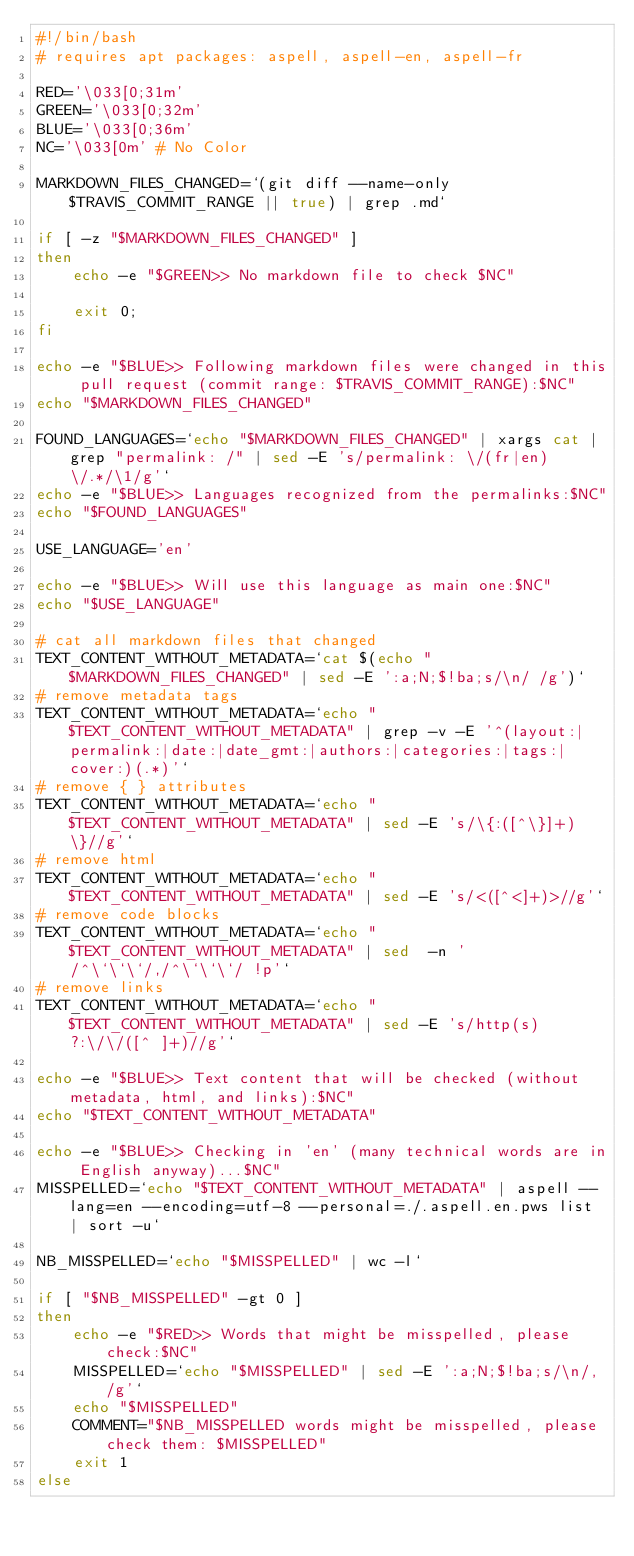<code> <loc_0><loc_0><loc_500><loc_500><_Bash_>#!/bin/bash
# requires apt packages: aspell, aspell-en, aspell-fr

RED='\033[0;31m'
GREEN='\033[0;32m'
BLUE='\033[0;36m'
NC='\033[0m' # No Color

MARKDOWN_FILES_CHANGED=`(git diff --name-only $TRAVIS_COMMIT_RANGE || true) | grep .md`

if [ -z "$MARKDOWN_FILES_CHANGED" ]
then
    echo -e "$GREEN>> No markdown file to check $NC"

    exit 0;
fi

echo -e "$BLUE>> Following markdown files were changed in this pull request (commit range: $TRAVIS_COMMIT_RANGE):$NC"
echo "$MARKDOWN_FILES_CHANGED"

FOUND_LANGUAGES=`echo "$MARKDOWN_FILES_CHANGED" | xargs cat | grep "permalink: /" | sed -E 's/permalink: \/(fr|en)\/.*/\1/g'`
echo -e "$BLUE>> Languages recognized from the permalinks:$NC"
echo "$FOUND_LANGUAGES"

USE_LANGUAGE='en'

echo -e "$BLUE>> Will use this language as main one:$NC"
echo "$USE_LANGUAGE"

# cat all markdown files that changed
TEXT_CONTENT_WITHOUT_METADATA=`cat $(echo "$MARKDOWN_FILES_CHANGED" | sed -E ':a;N;$!ba;s/\n/ /g')`
# remove metadata tags
TEXT_CONTENT_WITHOUT_METADATA=`echo "$TEXT_CONTENT_WITHOUT_METADATA" | grep -v -E '^(layout:|permalink:|date:|date_gmt:|authors:|categories:|tags:|cover:)(.*)'`
# remove { } attributes
TEXT_CONTENT_WITHOUT_METADATA=`echo "$TEXT_CONTENT_WITHOUT_METADATA" | sed -E 's/\{:([^\}]+)\}//g'`
# remove html
TEXT_CONTENT_WITHOUT_METADATA=`echo "$TEXT_CONTENT_WITHOUT_METADATA" | sed -E 's/<([^<]+)>//g'`
# remove code blocks
TEXT_CONTENT_WITHOUT_METADATA=`echo "$TEXT_CONTENT_WITHOUT_METADATA" | sed  -n '/^\`\`\`/,/^\`\`\`/ !p'`
# remove links
TEXT_CONTENT_WITHOUT_METADATA=`echo "$TEXT_CONTENT_WITHOUT_METADATA" | sed -E 's/http(s)?:\/\/([^ ]+)//g'`

echo -e "$BLUE>> Text content that will be checked (without metadata, html, and links):$NC"
echo "$TEXT_CONTENT_WITHOUT_METADATA"

echo -e "$BLUE>> Checking in 'en' (many technical words are in English anyway)...$NC"
MISSPELLED=`echo "$TEXT_CONTENT_WITHOUT_METADATA" | aspell --lang=en --encoding=utf-8 --personal=./.aspell.en.pws list | sort -u`

NB_MISSPELLED=`echo "$MISSPELLED" | wc -l`

if [ "$NB_MISSPELLED" -gt 0 ]
then
    echo -e "$RED>> Words that might be misspelled, please check:$NC"
    MISSPELLED=`echo "$MISSPELLED" | sed -E ':a;N;$!ba;s/\n/, /g'`
    echo "$MISSPELLED"
    COMMENT="$NB_MISSPELLED words might be misspelled, please check them: $MISSPELLED"
    exit 1
else</code> 